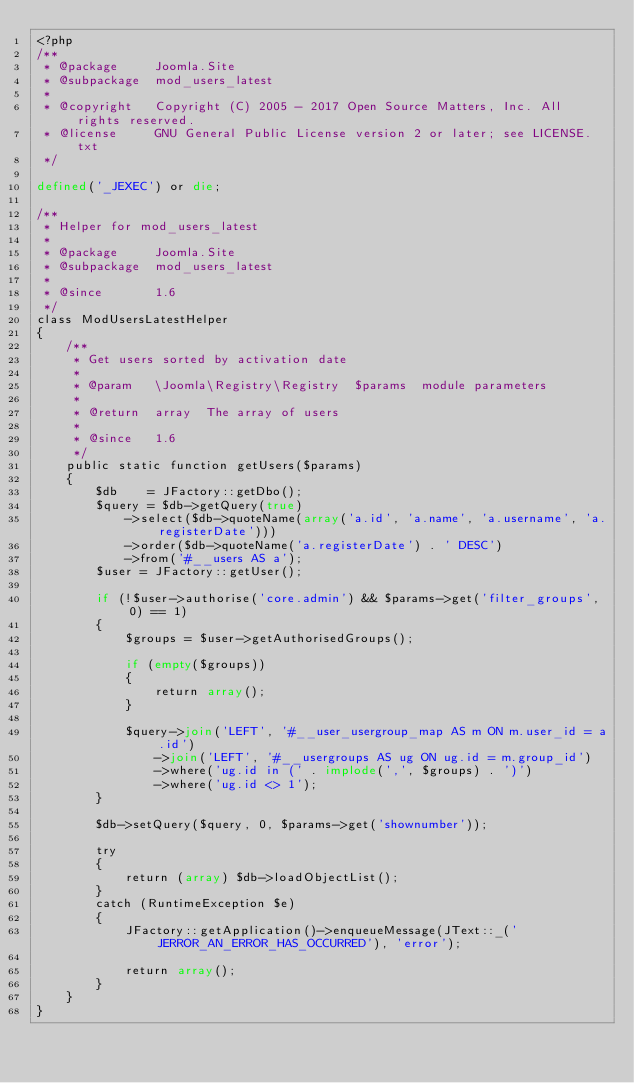<code> <loc_0><loc_0><loc_500><loc_500><_PHP_><?php
/**
 * @package     Joomla.Site
 * @subpackage  mod_users_latest
 *
 * @copyright   Copyright (C) 2005 - 2017 Open Source Matters, Inc. All rights reserved.
 * @license     GNU General Public License version 2 or later; see LICENSE.txt
 */

defined('_JEXEC') or die;

/**
 * Helper for mod_users_latest
 *
 * @package     Joomla.Site
 * @subpackage  mod_users_latest
 *
 * @since       1.6
 */
class ModUsersLatestHelper
{
	/**
	 * Get users sorted by activation date
	 *
	 * @param   \Joomla\Registry\Registry  $params  module parameters
	 *
	 * @return  array  The array of users
	 *
	 * @since   1.6
	 */
	public static function getUsers($params)
	{
		$db    = JFactory::getDbo();
		$query = $db->getQuery(true)
			->select($db->quoteName(array('a.id', 'a.name', 'a.username', 'a.registerDate')))
			->order($db->quoteName('a.registerDate') . ' DESC')
			->from('#__users AS a');
		$user = JFactory::getUser();

		if (!$user->authorise('core.admin') && $params->get('filter_groups', 0) == 1)
		{
			$groups = $user->getAuthorisedGroups();

			if (empty($groups))
			{
				return array();
			}

			$query->join('LEFT', '#__user_usergroup_map AS m ON m.user_id = a.id')
				->join('LEFT', '#__usergroups AS ug ON ug.id = m.group_id')
				->where('ug.id in (' . implode(',', $groups) . ')')
				->where('ug.id <> 1');
		}

		$db->setQuery($query, 0, $params->get('shownumber'));

		try
		{
			return (array) $db->loadObjectList();
		}
		catch (RuntimeException $e)
		{
			JFactory::getApplication()->enqueueMessage(JText::_('JERROR_AN_ERROR_HAS_OCCURRED'), 'error');

			return array();
		}
	}
}
</code> 